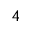<formula> <loc_0><loc_0><loc_500><loc_500>^ { 4 }</formula> 